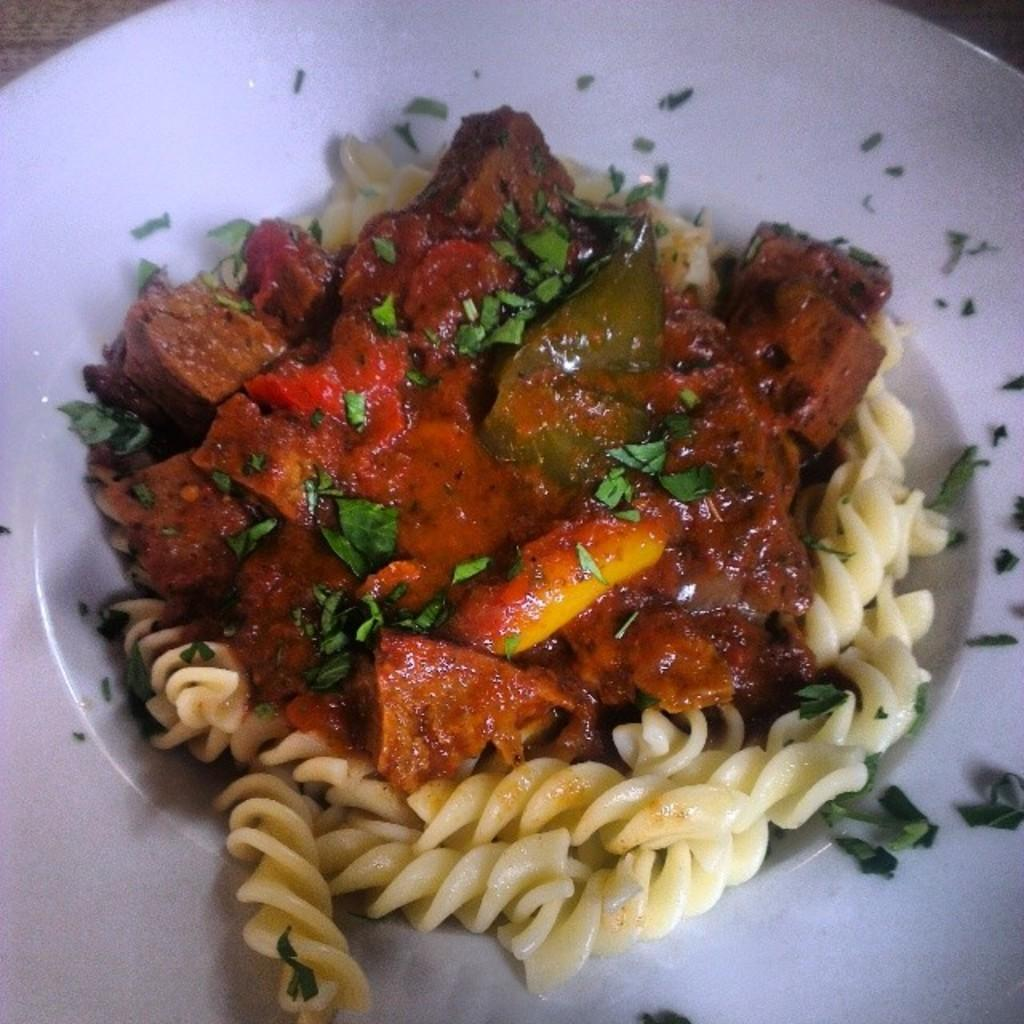What is on the plate in the image? There is a food item on the plate. What type of food is included in the food item? The food item contains pasta. Are there any additional ingredients in the food item? Yes, the food item includes pieces of green leaves. Can you describe any other components of the food item? Unfortunately, the facts provided do not specify any other components of the food item. What type of appliance is used to prepare the yam in the image? There is no yam present in the image, and therefore no appliance used to prepare it. 